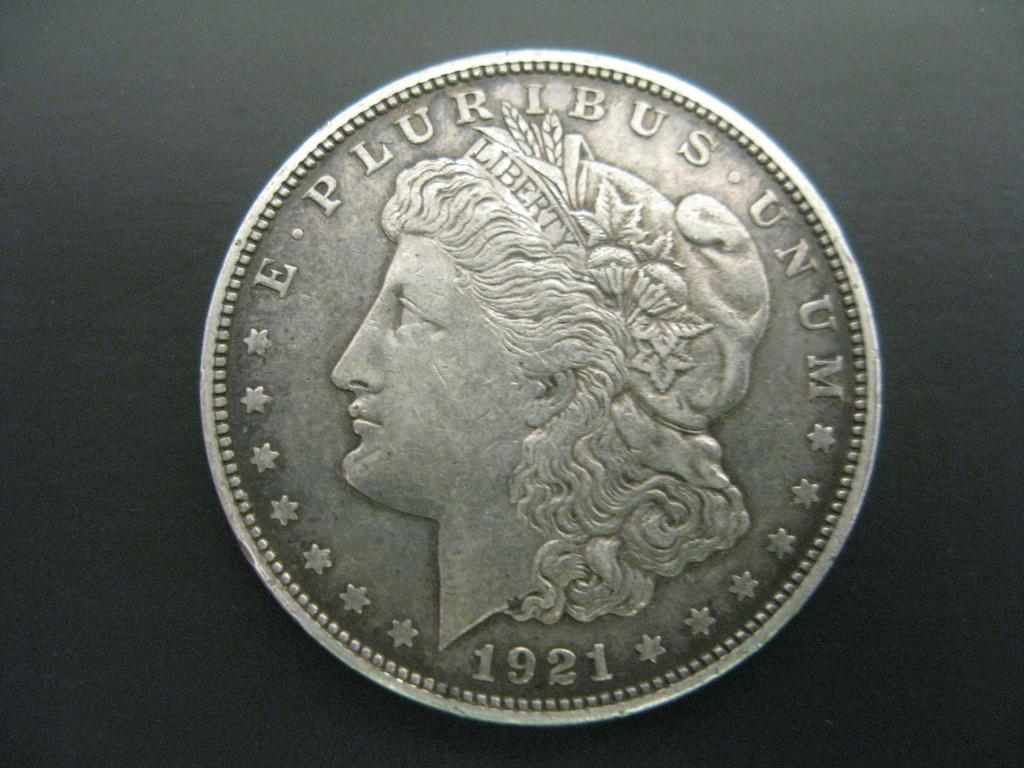What year was the coin minted?
Your answer should be very brief. 1921. What is written at the top of the coin?
Provide a short and direct response. E pluribus unum. 